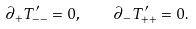<formula> <loc_0><loc_0><loc_500><loc_500>\partial _ { + } T ^ { \prime } _ { - - } = 0 , \quad \partial _ { - } T ^ { \prime } _ { + + } = 0 .</formula> 